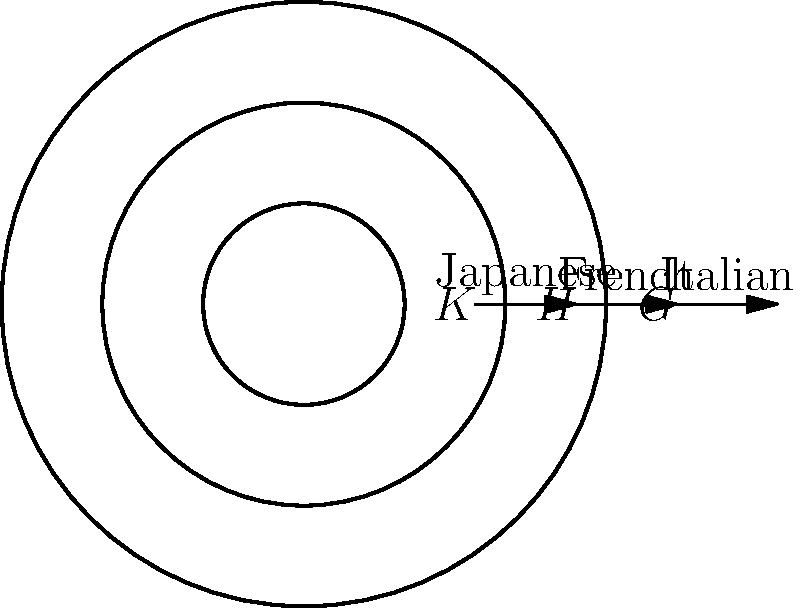In the diagram above, nested serving dishes from different culinary traditions represent normal subgroups of a group $G$. If $K \triangleleft H \triangleleft G$, where $K$ represents a Japanese dish, $H$ a French dish, and $G$ an Italian dish, which of the following statements is true about the quotient group $G/K$? Let's approach this step-by-step:

1) First, recall that if $K \triangleleft H \triangleleft G$, then $K \triangleleft G$ as well.

2) The quotient group $G/K$ consists of all cosets of $K$ in $G$.

3) Since $H$ is a normal subgroup of $G$, the cosets of $H$ in $G$ form a group, which we denote as $G/H$.

4) Similarly, since $K$ is a normal subgroup of $H$, the cosets of $K$ in $H$ form a group, denoted as $H/K$.

5) Now, consider the map $\phi: G/K \rightarrow G/H$ defined by $\phi(gK) = gH$ for any $g \in G$.

6) This map is well-defined and surjective. Its kernel is precisely $H/K$.

7) By the First Isomorphism Theorem, we have:

   $$(G/K)/(H/K) \cong G/H$$

8) This isomorphism shows that $G/K$ has a normal subgroup $H/K$, and the quotient of $G/K$ by $H/K$ is isomorphic to $G/H$.

9) In culinary terms, this means that the quotient group $G/K$ (Italian dish divided by Japanese dish) contains a normal subgroup $H/K$ (French dish divided by Japanese dish), and when we further quotient by this, we get something equivalent to $G/H$ (Italian dish divided by French dish).
Answer: $(G/K)/(H/K) \cong G/H$ 